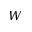<formula> <loc_0><loc_0><loc_500><loc_500>W</formula> 